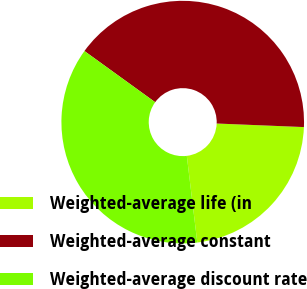Convert chart to OTSL. <chart><loc_0><loc_0><loc_500><loc_500><pie_chart><fcel>Weighted-average life (in<fcel>Weighted-average constant<fcel>Weighted-average discount rate<nl><fcel>22.43%<fcel>40.68%<fcel>36.88%<nl></chart> 